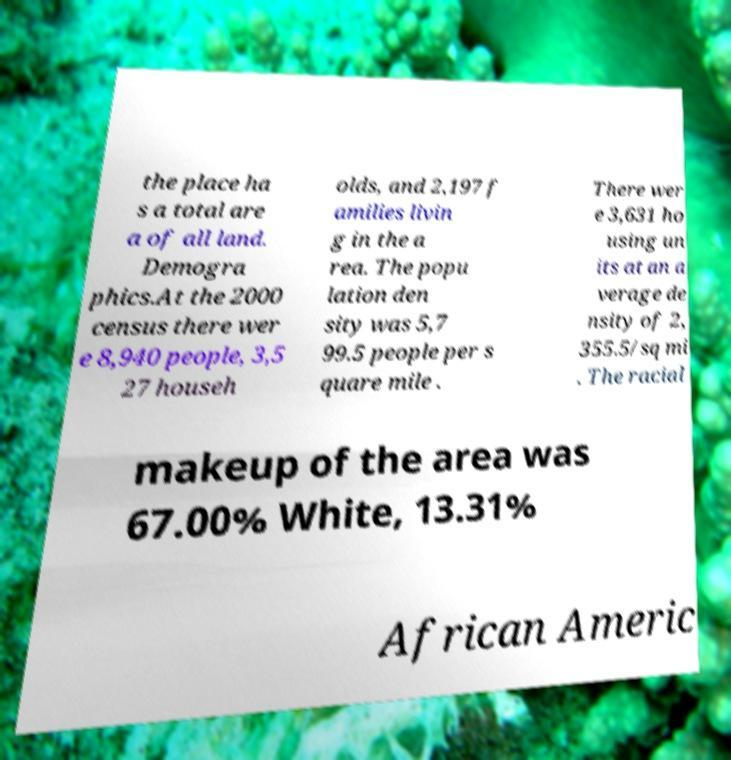Can you accurately transcribe the text from the provided image for me? the place ha s a total are a of all land. Demogra phics.At the 2000 census there wer e 8,940 people, 3,5 27 househ olds, and 2,197 f amilies livin g in the a rea. The popu lation den sity was 5,7 99.5 people per s quare mile . There wer e 3,631 ho using un its at an a verage de nsity of 2, 355.5/sq mi . The racial makeup of the area was 67.00% White, 13.31% African Americ 